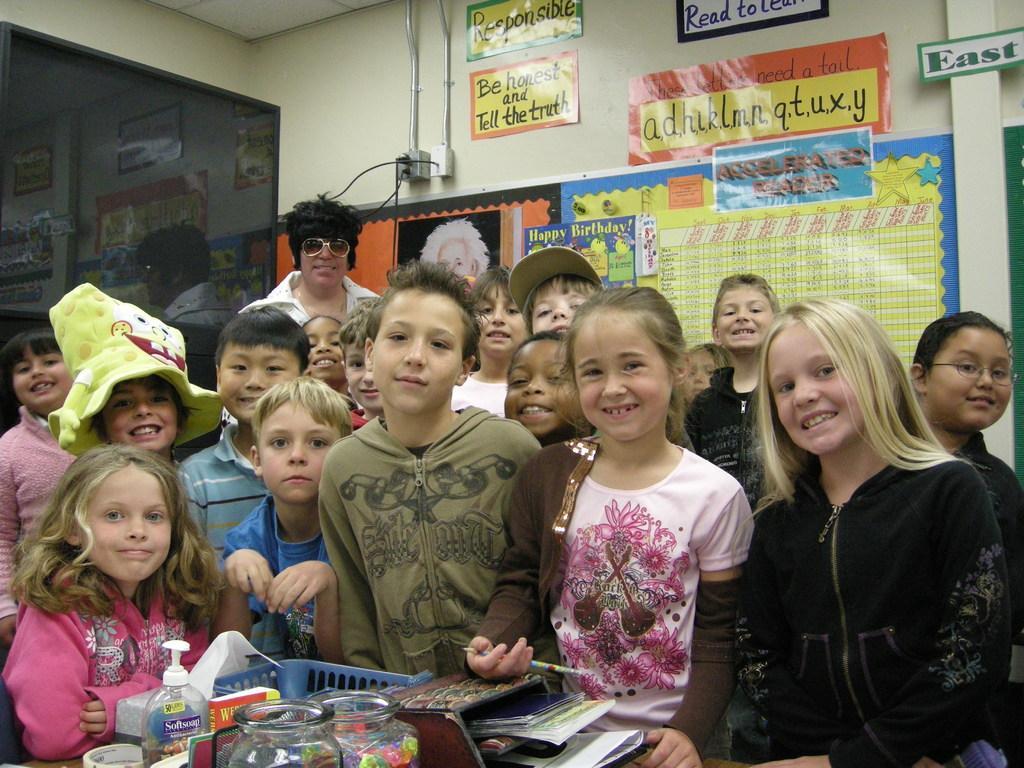Describe this image in one or two sentences. In the image in the center, we can see little kids are standing and they are smiling, which we can see on their faces. In front of them, there is a table. On the table, we can see books, baskets, jars, tape, spray bottle and a few other objects. In the background there is a wall, roof, screen, posters, one person standing and he is smiling etc. 